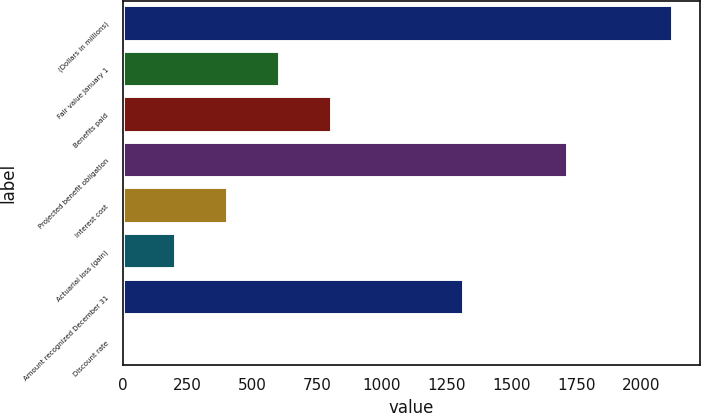<chart> <loc_0><loc_0><loc_500><loc_500><bar_chart><fcel>(Dollars in millions)<fcel>Fair value January 1<fcel>Benefits paid<fcel>Projected benefit obligation<fcel>Interest cost<fcel>Actuarial loss (gain)<fcel>Amount recognized December 31<fcel>Discount rate<nl><fcel>2122.11<fcel>606.84<fcel>807.87<fcel>1720.06<fcel>405.81<fcel>204.78<fcel>1318<fcel>3.75<nl></chart> 